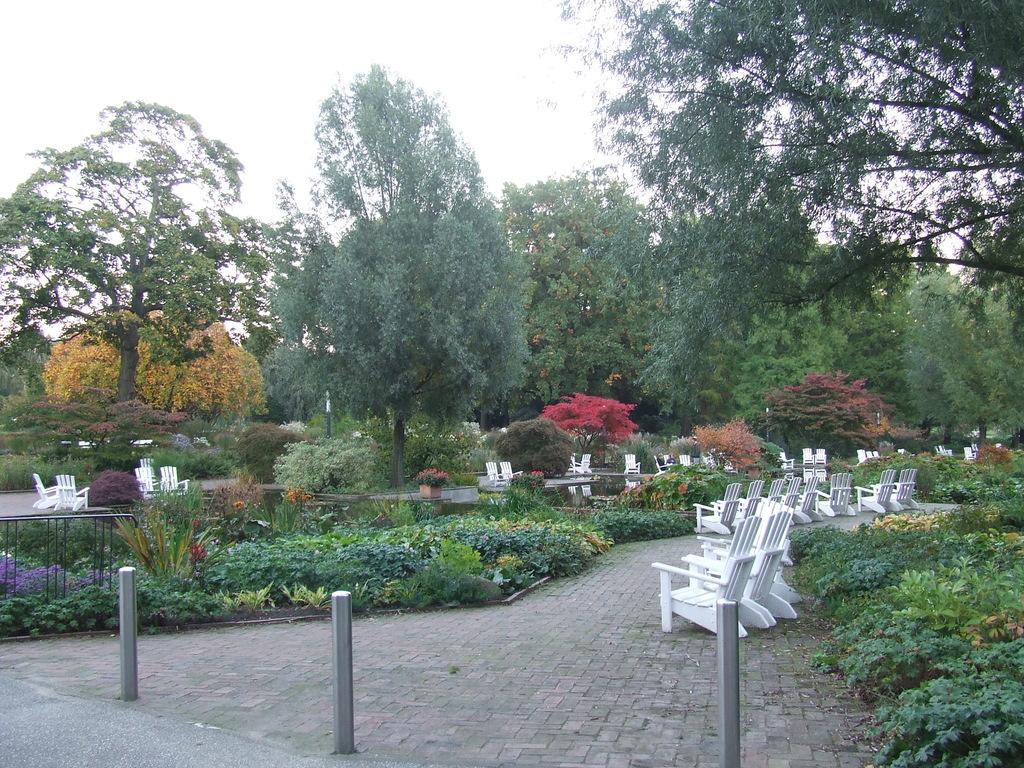What type of vegetation can be seen in the image? There are trees, plants, and flowers in the image. How are the chairs arranged in the image? The chairs are arranged in a path in the image. What can be seen in the background of the image? The sky is visible in the background of the image. What other objects are present in the image besides the chairs and vegetation? There are a few rods in the image. How many books are stacked on the lace tablecloth in the image? There are no books or lace tablecloth present in the image. 